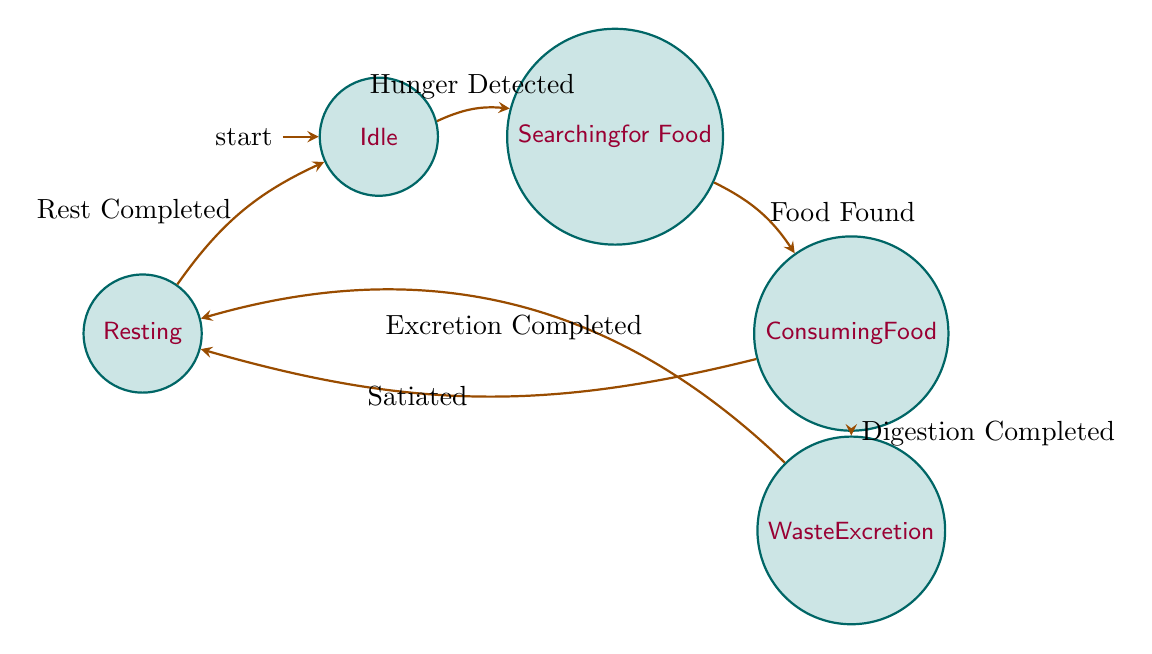What's the initial state of the machine? The diagram indicates that the initial state of the machine is the node labeled "Idle." This is where the process begins before any transitions occur.
Answer: Idle How many states are present in the diagram? By counting the nodes in the diagram, there are five distinct states: Idle, Searching for Food, Consuming Food, Resting, and Waste Excretion.
Answer: 5 What transition occurs after "Searching for Food"? The transition from "Searching for Food" leads to the "Consuming Food" state when the trigger "Food Found" occurs, indicating that the crab has successfully located food.
Answer: Consuming Food Which state follows "Waste Excretion"? After the "Waste Excretion" state, the next state is "Resting," triggered by the completion of excretion as indicated by the "Excretion Completed" transition.
Answer: Resting What is the trigger for transitioning from "Consuming Food" to "Resting"? The trigger for this transition is "Satiated," which indicates that the crab has eaten enough food and is now ready to rest.
Answer: Satiated Is there a state that has two outgoing transitions? Yes, the "Consuming Food" state has two outgoing transitions: one going to "Resting" triggered by "Satiated," and another leading to "Waste Excretion" triggered by "Digestion Completed."
Answer: Yes What is the relationship between "Idle" and "Searching for Food"? The relationship is a transition, where "Idle" moves to "Searching for Food" when the trigger "Hunger Detected" occurs. This indicates the crab becomes active when it detects hunger.
Answer: Transition How does the process return to "Idle"? The process returns to "Idle" from "Resting" once the trigger "Rest Completed" occurs, suggesting the crab is ready to start its feeding routine again.
Answer: Rest Completed 